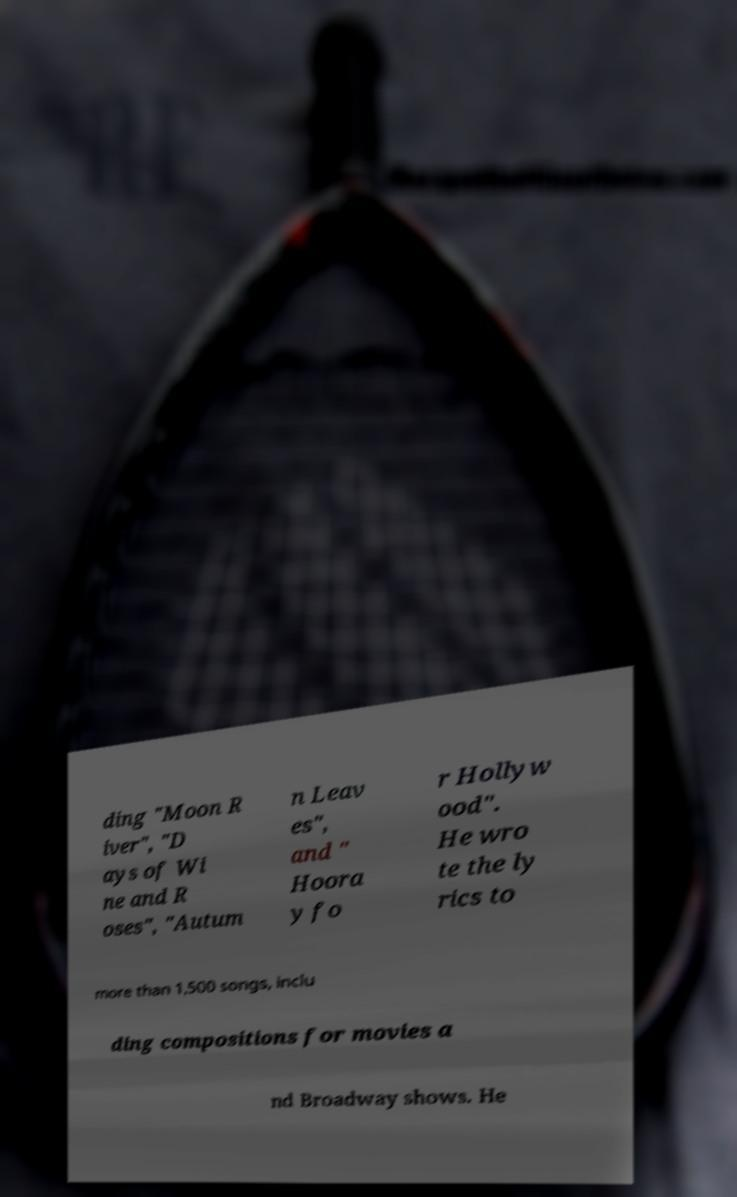What messages or text are displayed in this image? I need them in a readable, typed format. ding "Moon R iver", "D ays of Wi ne and R oses", "Autum n Leav es", and " Hoora y fo r Hollyw ood". He wro te the ly rics to more than 1,500 songs, inclu ding compositions for movies a nd Broadway shows. He 